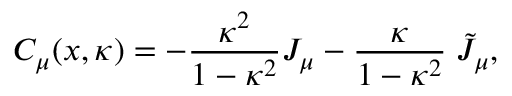<formula> <loc_0><loc_0><loc_500><loc_500>C _ { \mu } ( x , \kappa ) = - \frac { \kappa ^ { 2 } } { 1 - \kappa ^ { 2 } } J _ { \mu } - \frac { \kappa } 1 - \kappa ^ { 2 } } \, \tilde { J } _ { \mu } ,</formula> 